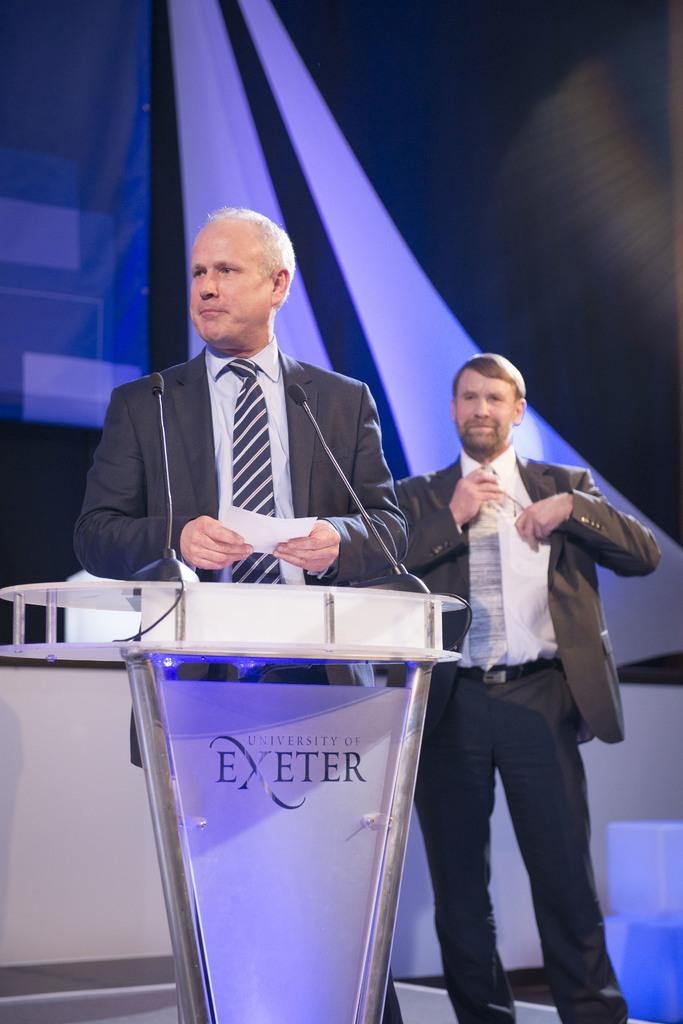<image>
Summarize the visual content of the image. A man at a podium that reads University of Exeter. 